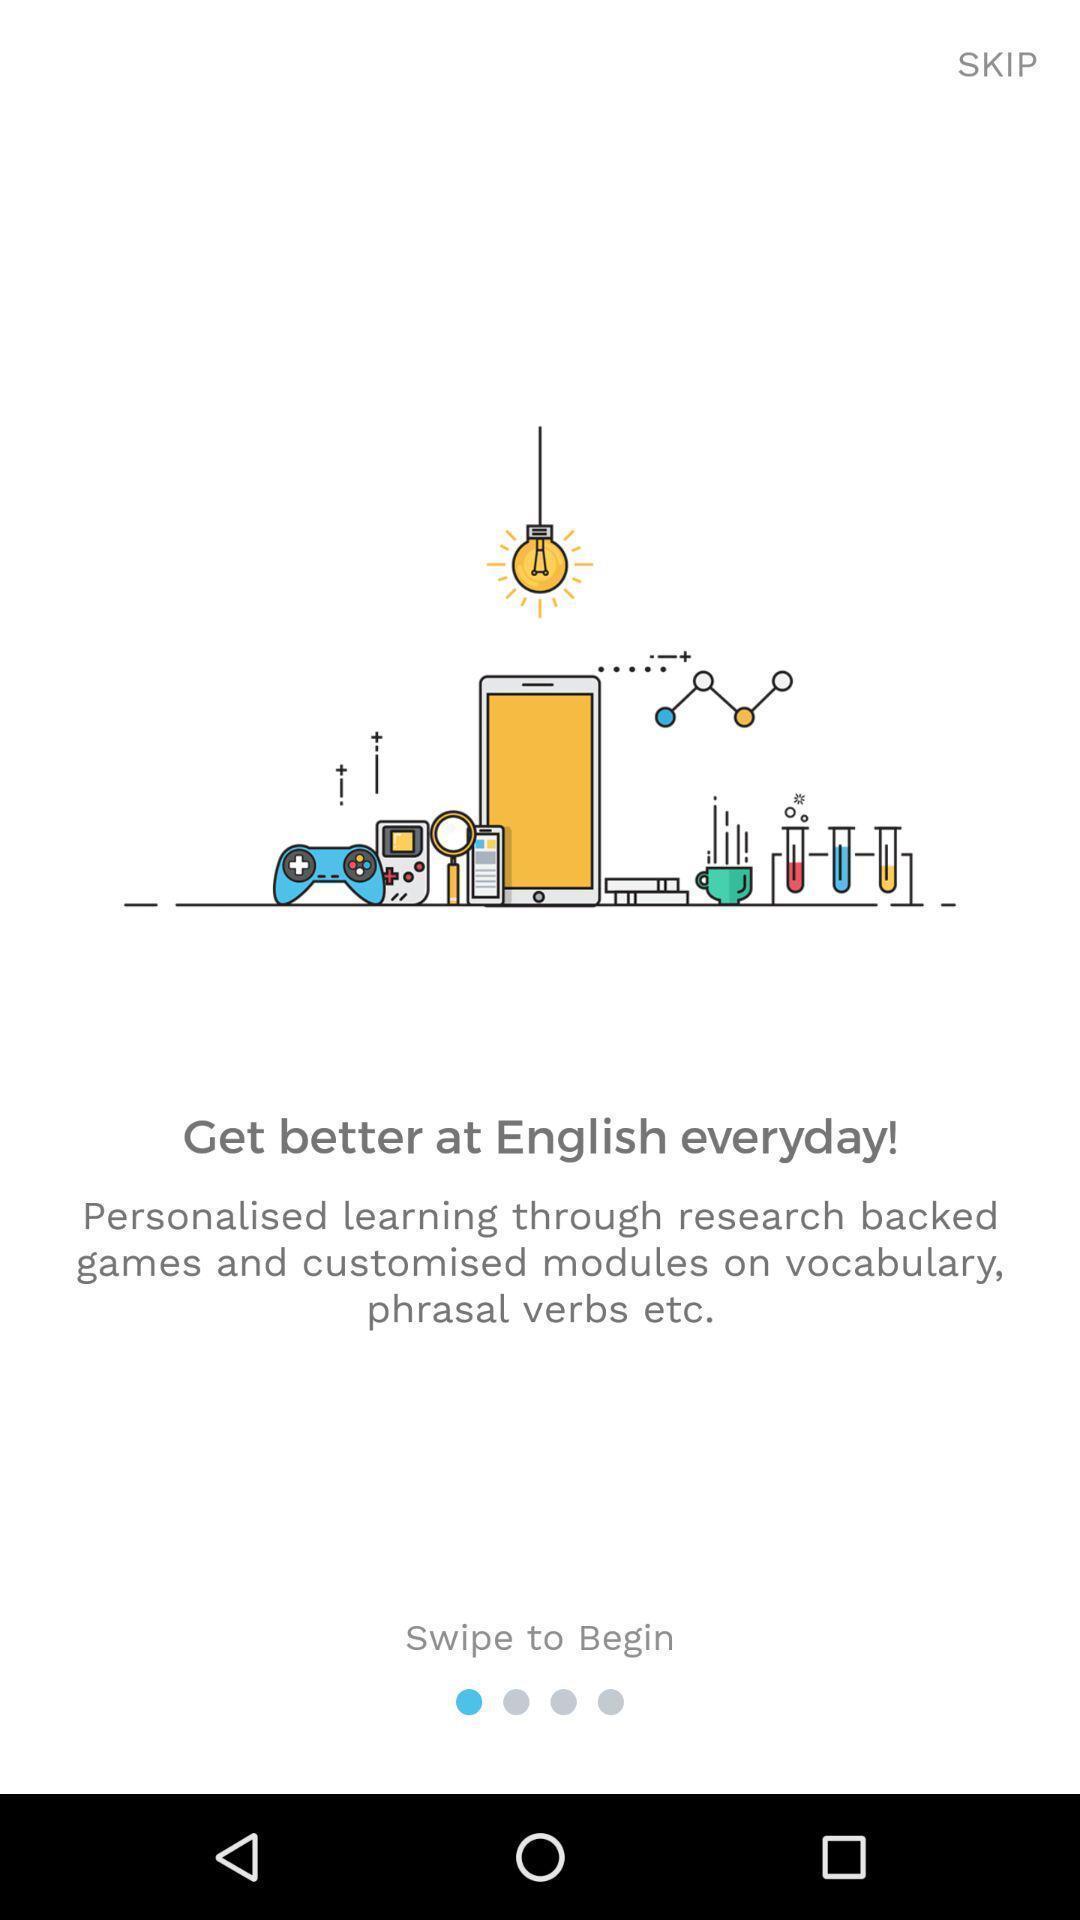Give me a summary of this screen capture. Screen shows welcome page. 